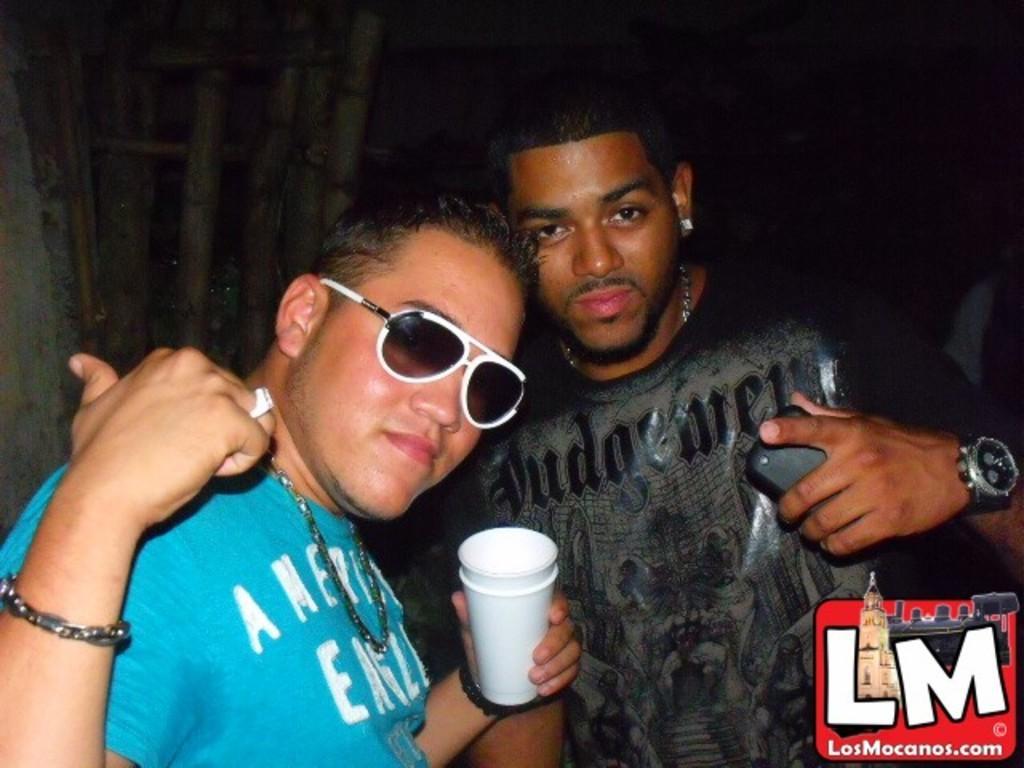Describe this image in one or two sentences. In the picture we can see two men are standing, one man is holding a glass and wearing a shade and blue T-shirt and one man is wearing a black T-shirt and holding something in hand and behind them we can see dark. 